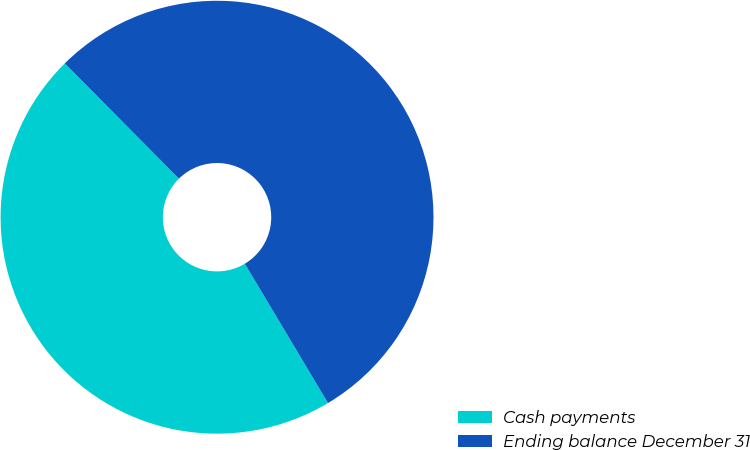<chart> <loc_0><loc_0><loc_500><loc_500><pie_chart><fcel>Cash payments<fcel>Ending balance December 31<nl><fcel>46.15%<fcel>53.85%<nl></chart> 